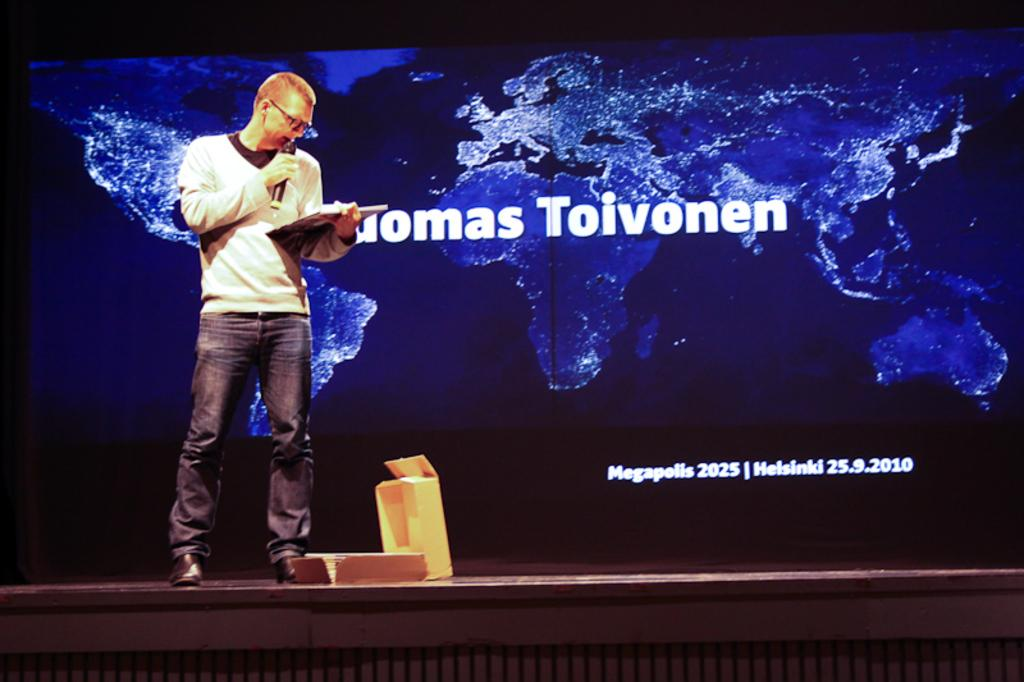<image>
Give a short and clear explanation of the subsequent image. man on stage reading from book and background of map of the world behind him that has word Toivonen in white letters 